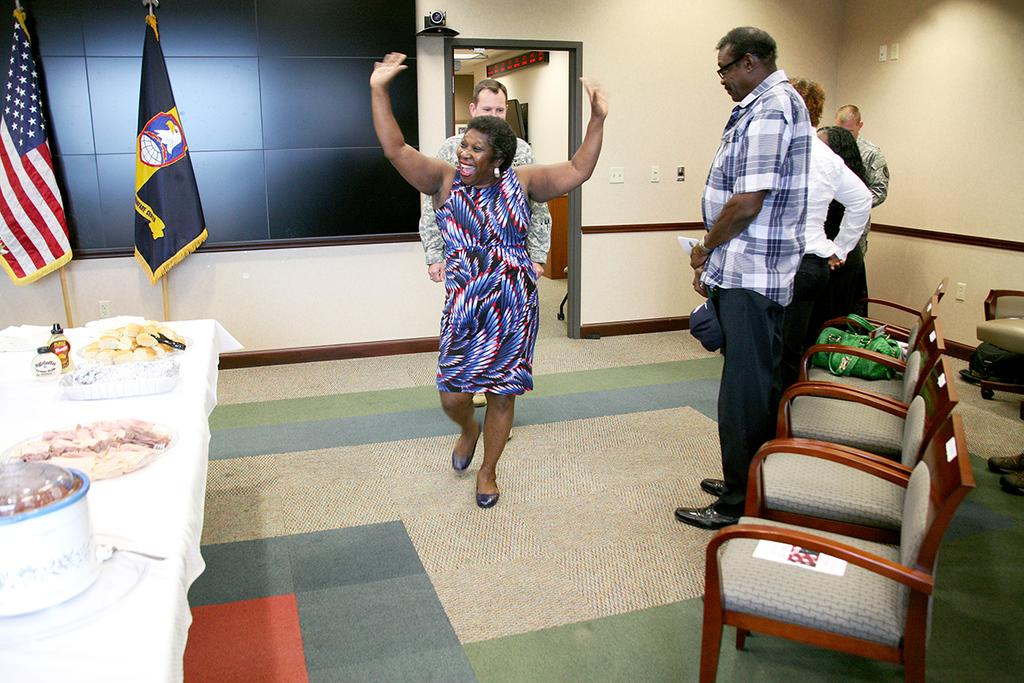What are the people doing near the chair in the image? The facts do not specify what the people are doing near the chair. What can be found on the table in the image? There is food and a bottle on the table in the image. What is located near the table in the image? There is a flag near the table in the image. Can you hear the horn in the image? There is no mention of a horn in the image, so it cannot be heard. What type of rake is being used to clean the space in the image? There is no rake or space mentioned in the image, so this question cannot be answered. 